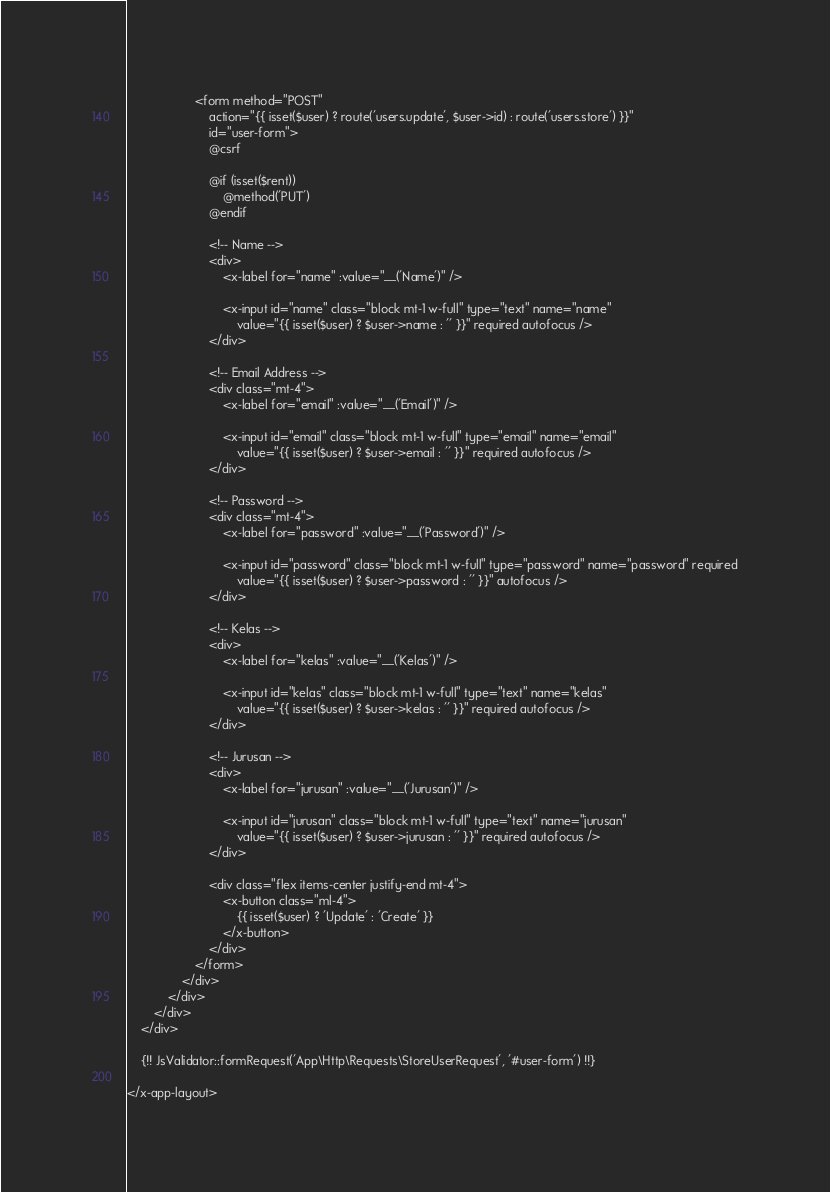<code> <loc_0><loc_0><loc_500><loc_500><_PHP_>                    <form method="POST"
                        action="{{ isset($user) ? route('users.update', $user->id) : route('users.store') }}"
                        id="user-form">
                        @csrf

                        @if (isset($rent))
                            @method('PUT')
                        @endif

                        <!-- Name -->
                        <div>
                            <x-label for="name" :value="__('Name')" />

                            <x-input id="name" class="block mt-1 w-full" type="text" name="name"
                                value="{{ isset($user) ? $user->name : '' }}" required autofocus />
                        </div>

                        <!-- Email Address -->
                        <div class="mt-4">
                            <x-label for="email" :value="__('Email')" />

                            <x-input id="email" class="block mt-1 w-full" type="email" name="email"
                                value="{{ isset($user) ? $user->email : '' }}" required autofocus />
                        </div>

                        <!-- Password -->
                        <div class="mt-4">
                            <x-label for="password" :value="__('Password')" />

                            <x-input id="password" class="block mt-1 w-full" type="password" name="password" required
                                value="{{ isset($user) ? $user->password : '' }}" autofocus />
                        </div>

                        <!-- Kelas -->
                        <div>
                            <x-label for="kelas" :value="__('Kelas')" />

                            <x-input id="kelas" class="block mt-1 w-full" type="text" name="kelas"
                                value="{{ isset($user) ? $user->kelas : '' }}" required autofocus />
                        </div>

                        <!-- Jurusan -->
                        <div>
                            <x-label for="jurusan" :value="__('Jurusan')" />

                            <x-input id="jurusan" class="block mt-1 w-full" type="text" name="jurusan"
                                value="{{ isset($user) ? $user->jurusan : '' }}" required autofocus />
                        </div>

                        <div class="flex items-center justify-end mt-4">
                            <x-button class="ml-4">
                                {{ isset($user) ? 'Update' : 'Create' }}
                            </x-button>
                        </div>
                    </form>
                </div>
            </div>
        </div>
    </div>

    {!! JsValidator::formRequest('App\Http\Requests\StoreUserRequest', '#user-form') !!}

</x-app-layout>
</code> 